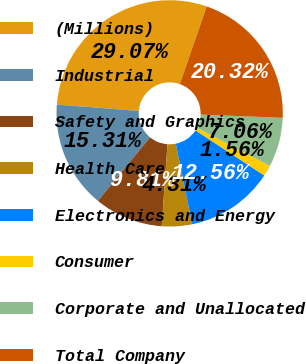Convert chart. <chart><loc_0><loc_0><loc_500><loc_500><pie_chart><fcel>(Millions)<fcel>Industrial<fcel>Safety and Graphics<fcel>Health Care<fcel>Electronics and Energy<fcel>Consumer<fcel>Corporate and Unallocated<fcel>Total Company<nl><fcel>29.07%<fcel>15.31%<fcel>9.81%<fcel>4.31%<fcel>12.56%<fcel>1.56%<fcel>7.06%<fcel>20.32%<nl></chart> 